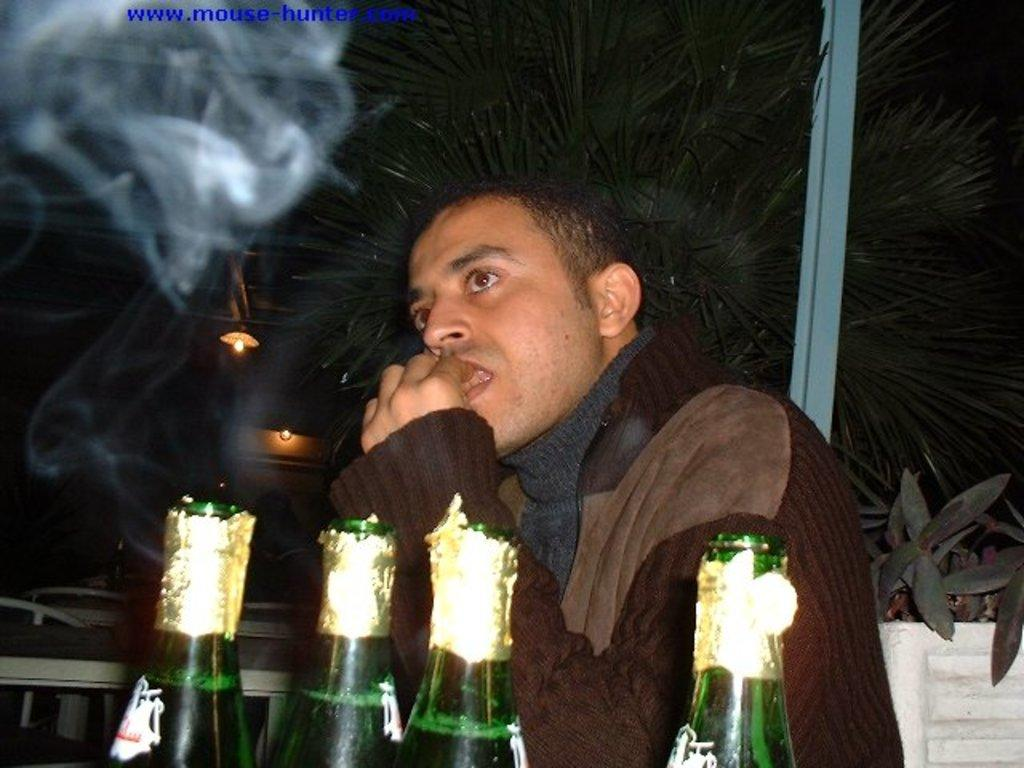Who is present in the image? There is a man in the image. What objects can be seen on the table in the image? There are four bottles on the table. What type of furniture is visible at the back of the image? There are tables and chairs at the back of the image. What can be seen at the top of the image? There are lights visible at the top of the image. What is located behind the man in the image? There is a tree behind the man. How many women are present in the image? There are no women present in the image; only a man is visible. What type of zipper can be seen on the man's clothing in the image? There is no zipper visible on the man's clothing in the image. 